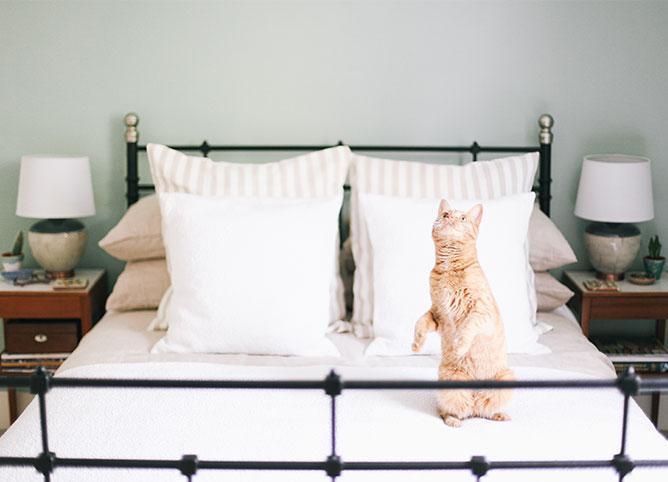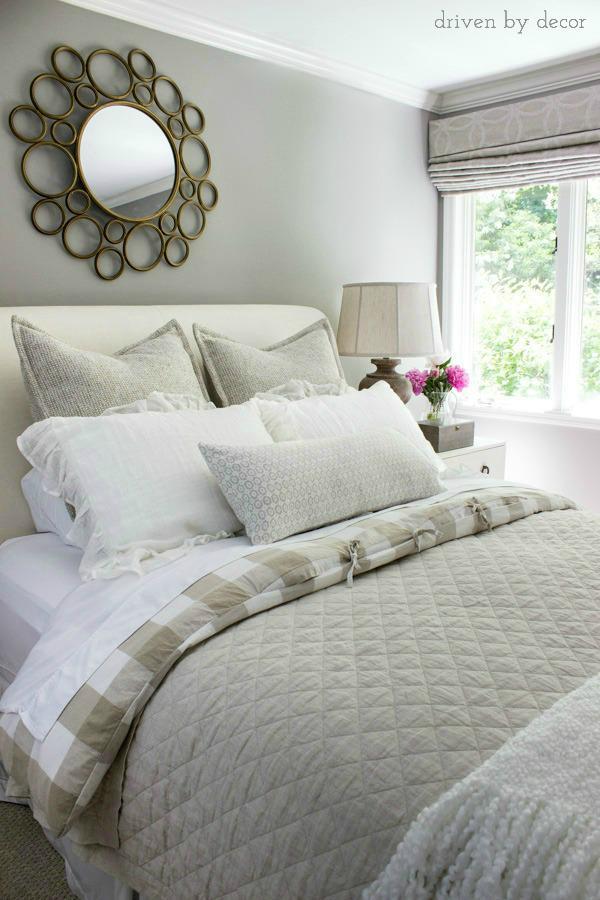The first image is the image on the left, the second image is the image on the right. Evaluate the accuracy of this statement regarding the images: "An image of a bedroom features bare branches somewhere in the decor.". Is it true? Answer yes or no. No. The first image is the image on the left, the second image is the image on the right. Evaluate the accuracy of this statement regarding the images: "There are lamps on each side of a bed". Is it true? Answer yes or no. Yes. 